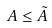<formula> <loc_0><loc_0><loc_500><loc_500>A \leq \tilde { A }</formula> 